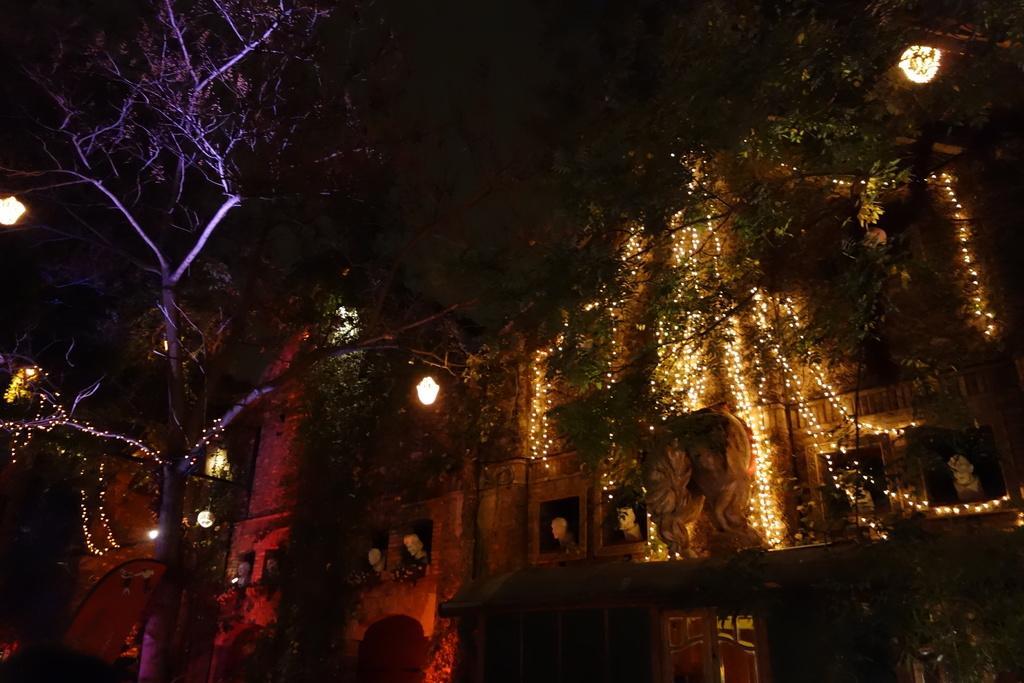Can you describe this image briefly? In this picture we can observe some trees. We can observe yellow color lights. In the background there is a building which is decorated with some lights. On the left side we can observe a tree decorated with lights. 